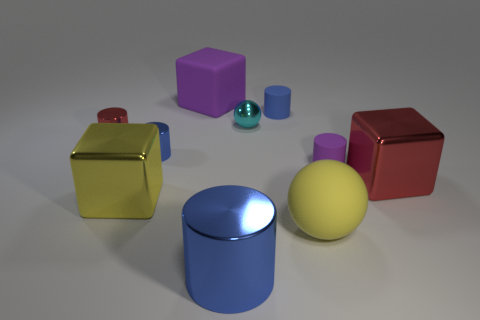What size is the yellow thing that is the same material as the small cyan object?
Offer a very short reply. Large. How many objects are either yellow spheres that are behind the large blue metal thing or metallic blocks left of the big metal cylinder?
Provide a short and direct response. 2. Is the size of the cylinder behind the shiny ball the same as the large blue cylinder?
Keep it short and to the point. No. The ball behind the tiny purple cylinder is what color?
Provide a succinct answer. Cyan. There is a large matte thing that is the same shape as the yellow metallic object; what color is it?
Offer a terse response. Purple. There is a blue object on the left side of the big matte cube that is behind the yellow shiny object; how many big shiny cubes are in front of it?
Give a very brief answer. 2. Are there fewer small metal spheres in front of the tiny cyan metallic sphere than large metallic objects?
Provide a succinct answer. Yes. There is another rubber thing that is the same shape as the cyan object; what is its size?
Keep it short and to the point. Large. What number of tiny objects have the same material as the tiny sphere?
Ensure brevity in your answer.  2. Is the material of the ball behind the big yellow metallic block the same as the big yellow sphere?
Give a very brief answer. No. 